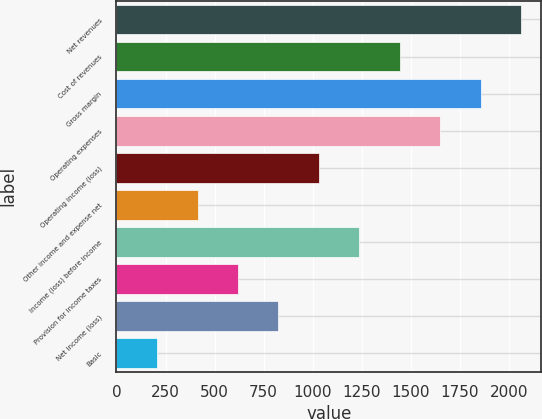Convert chart to OTSL. <chart><loc_0><loc_0><loc_500><loc_500><bar_chart><fcel>Net revenues<fcel>Cost of revenues<fcel>Gross margin<fcel>Operating expenses<fcel>Operating income (loss)<fcel>Other income and expense net<fcel>Income (loss) before income<fcel>Provision for income taxes<fcel>Net income (loss)<fcel>Basic<nl><fcel>2064<fcel>1444.96<fcel>1857.64<fcel>1651.3<fcel>1032.28<fcel>413.26<fcel>1238.62<fcel>619.6<fcel>825.94<fcel>206.92<nl></chart> 